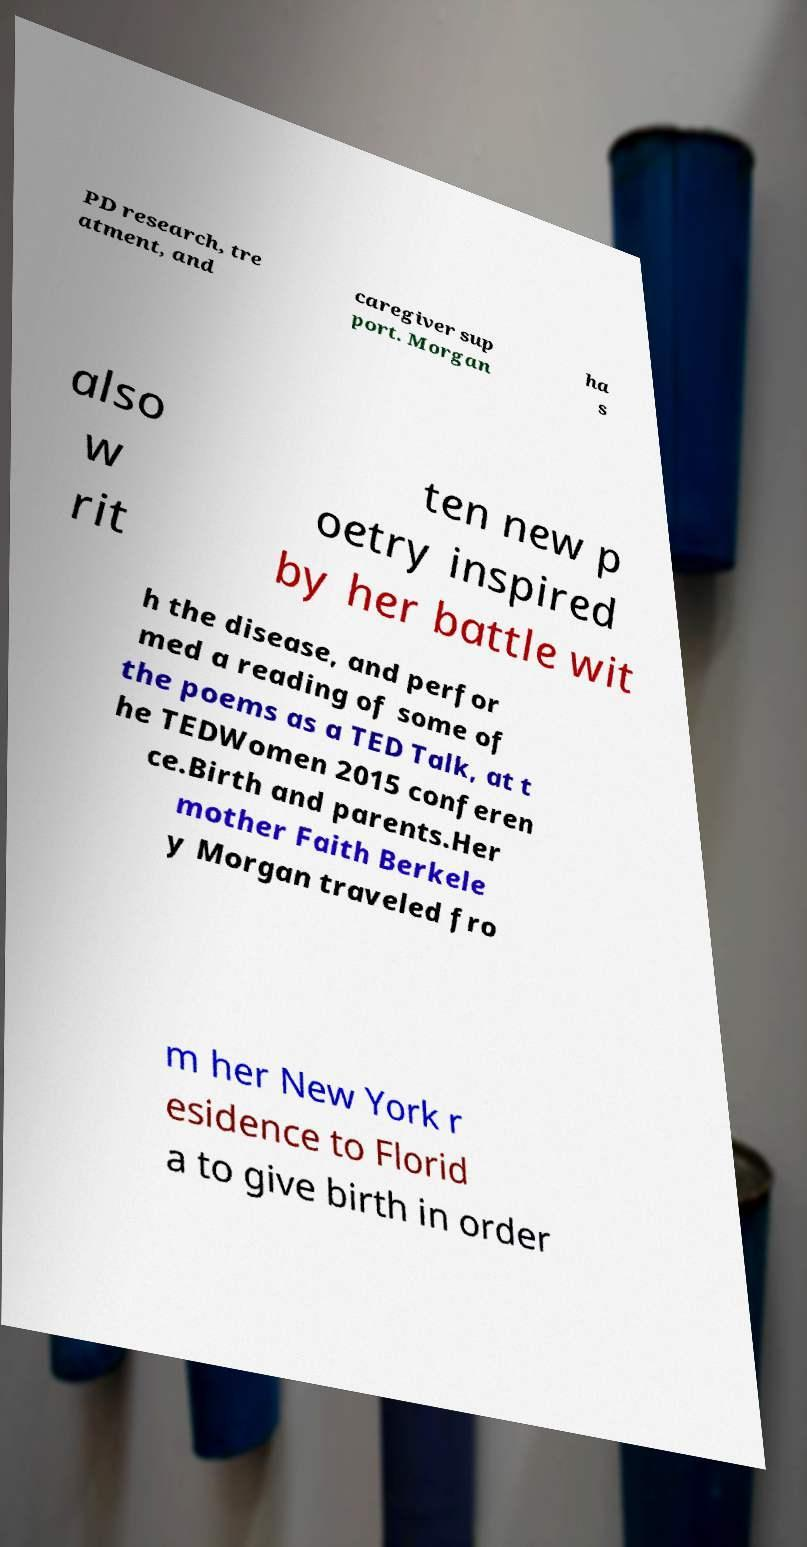Could you extract and type out the text from this image? PD research, tre atment, and caregiver sup port. Morgan ha s also w rit ten new p oetry inspired by her battle wit h the disease, and perfor med a reading of some of the poems as a TED Talk, at t he TEDWomen 2015 conferen ce.Birth and parents.Her mother Faith Berkele y Morgan traveled fro m her New York r esidence to Florid a to give birth in order 